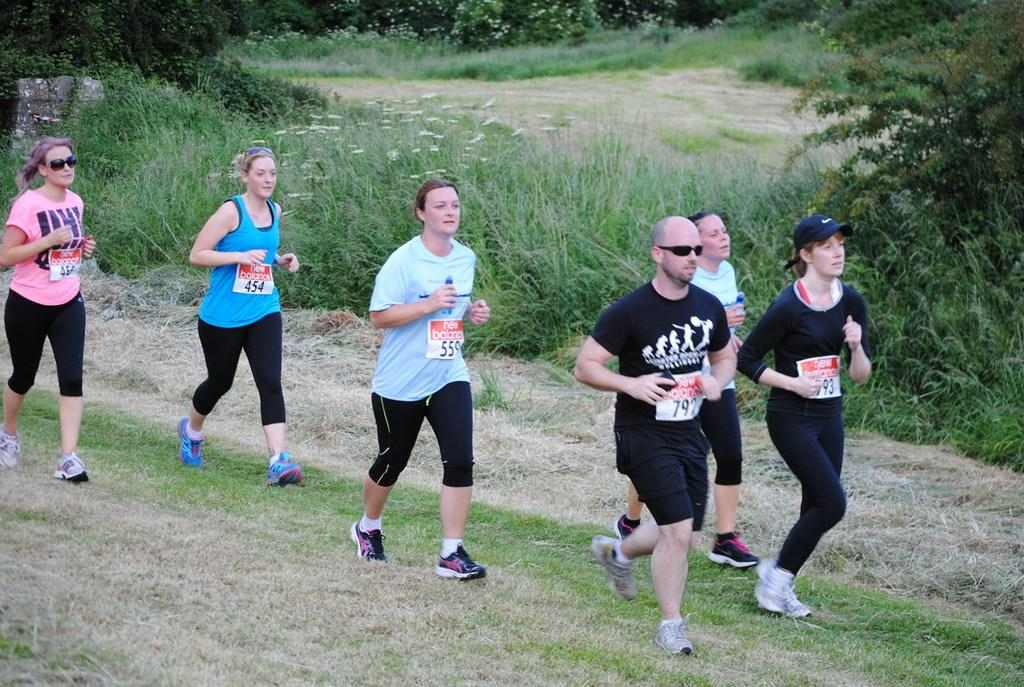What is happening in the image involving a group of people? The people in the image are running. Where are the people running in the image? The running is taking place on a grassy land. What can be seen in the background of the image? There are plants and trees in the background of the image. What language are the people speaking while running in the image? There is no information about the language spoken by the people in the image. Can you see any icicles hanging from the trees in the background of the image? There are no icicles present in the image, as it features people running on a grassy land with trees in the background. 